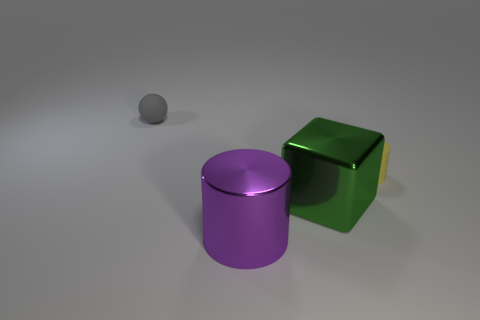The green thing is what size?
Keep it short and to the point. Large. Is the number of large shiny cylinders behind the big green metal cube greater than the number of tiny cyan blocks?
Your response must be concise. No. There is a tiny yellow matte cylinder; how many large green cubes are to the right of it?
Give a very brief answer. 0. Are there any red cubes that have the same size as the yellow matte cylinder?
Make the answer very short. No. There is another thing that is the same shape as the purple metal object; what is its color?
Keep it short and to the point. Yellow. There is a matte thing that is in front of the small ball; is its size the same as the object that is left of the large purple shiny cylinder?
Your response must be concise. Yes. Is there another green thing that has the same shape as the green thing?
Provide a short and direct response. No. Is the number of big purple shiny cylinders that are to the left of the large cylinder the same as the number of red metal spheres?
Provide a short and direct response. Yes. Does the rubber cylinder have the same size as the metallic object to the left of the green shiny block?
Keep it short and to the point. No. What number of other things are made of the same material as the tiny gray object?
Offer a very short reply. 1. 